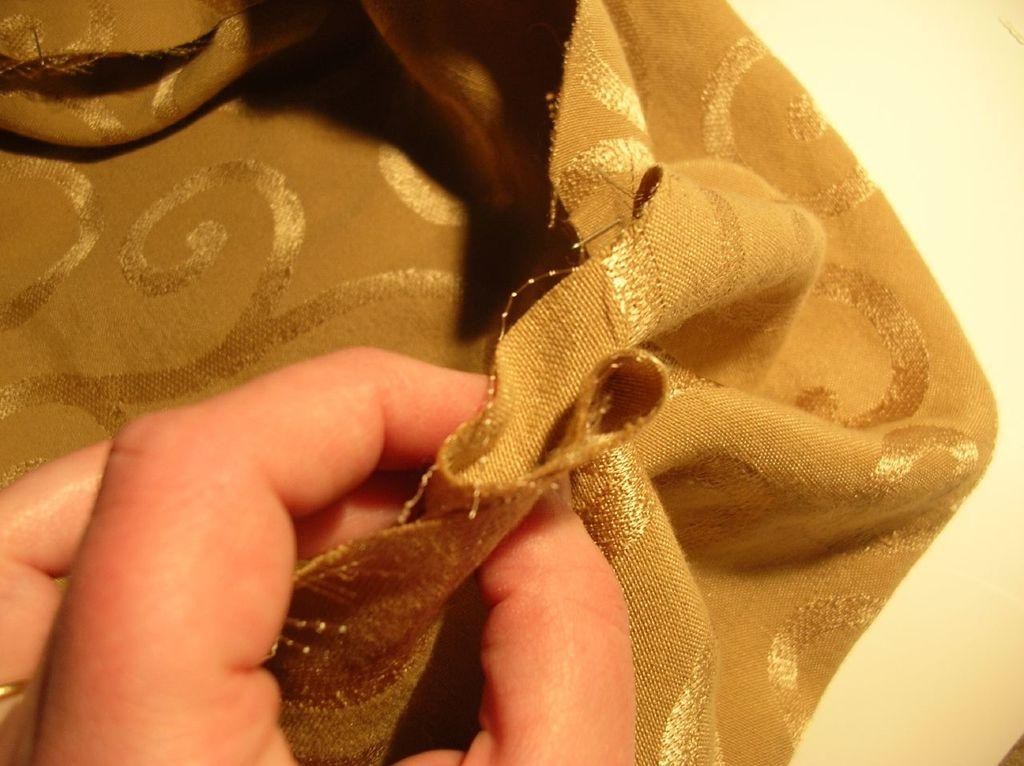What can be seen in the image? There is a person's hand in the image. What is the hand holding? The hand is holding a brown-colored cloth. How many chickens are visible in the image? There are no chickens present in the image; it only shows a person's hand holding a brown-colored cloth. What type of root can be seen growing in the image? There is no root visible in the image; it only shows a person's hand holding a brown-colored cloth. 